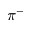<formula> <loc_0><loc_0><loc_500><loc_500>\pi ^ { - }</formula> 